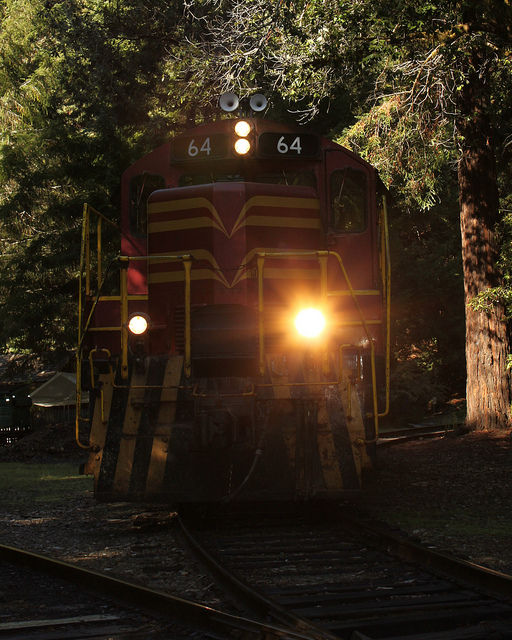Identify the text displayed in this image. 64 64 